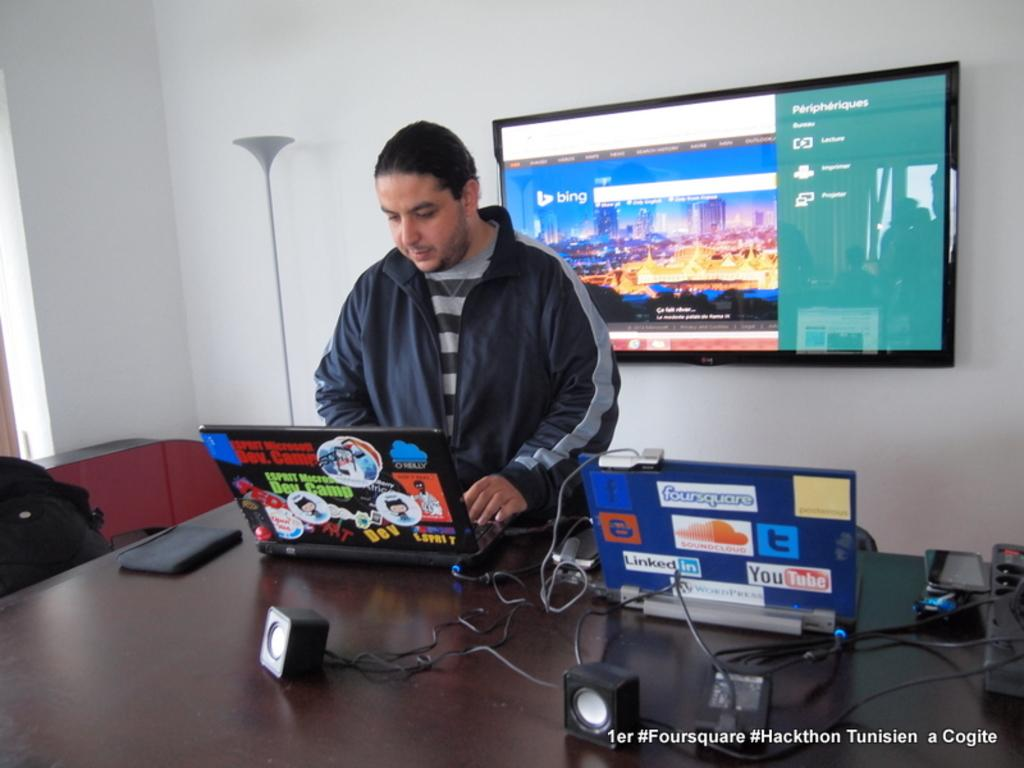<image>
Offer a succinct explanation of the picture presented. A man works on a computer with Dev. Camp stickers all over it next to another computer 